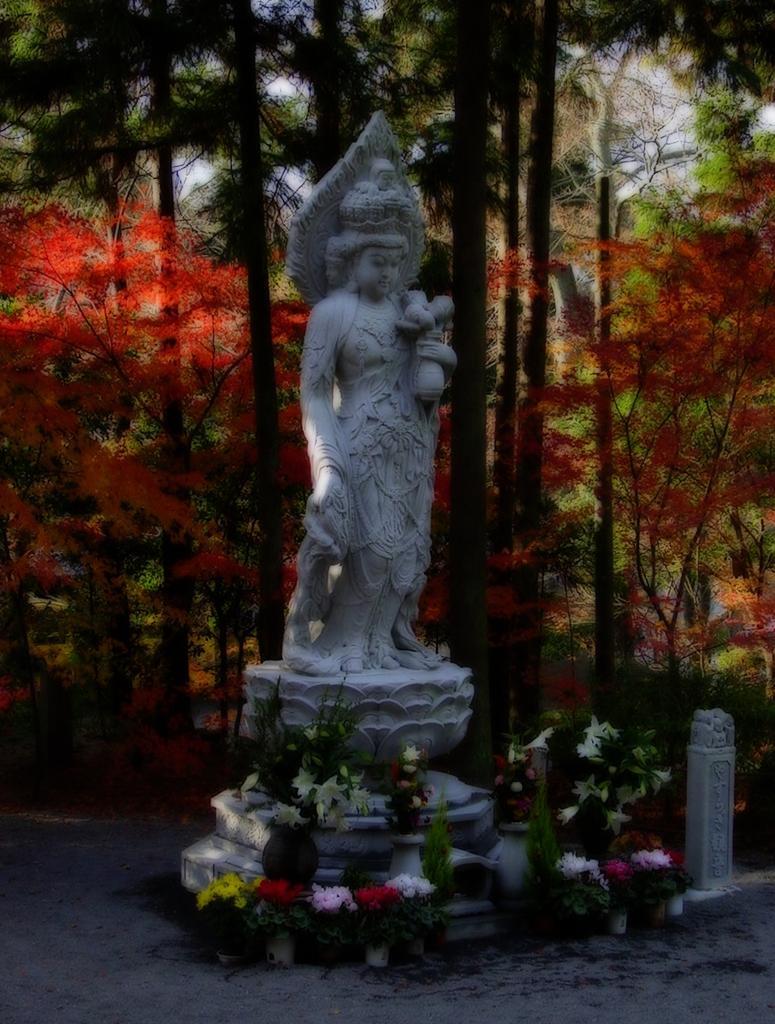How would you summarize this image in a sentence or two? In this image we can see a sculpture, at the back there are the trees, here are the flower pots on the ground. 